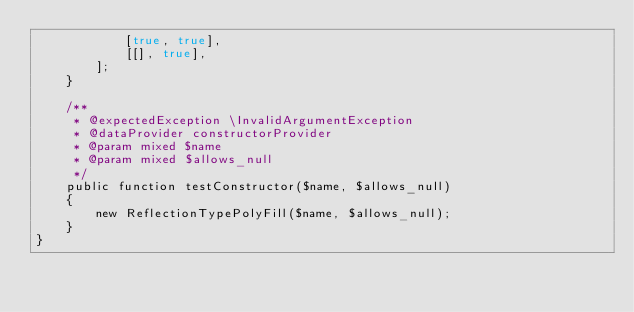<code> <loc_0><loc_0><loc_500><loc_500><_PHP_>            [true, true],
            [[], true],
        ];
    }

    /**
     * @expectedException \InvalidArgumentException
     * @dataProvider constructorProvider
     * @param mixed $name
     * @param mixed $allows_null
     */
    public function testConstructor($name, $allows_null)
    {
        new ReflectionTypePolyFill($name, $allows_null);
    }
}
</code> 